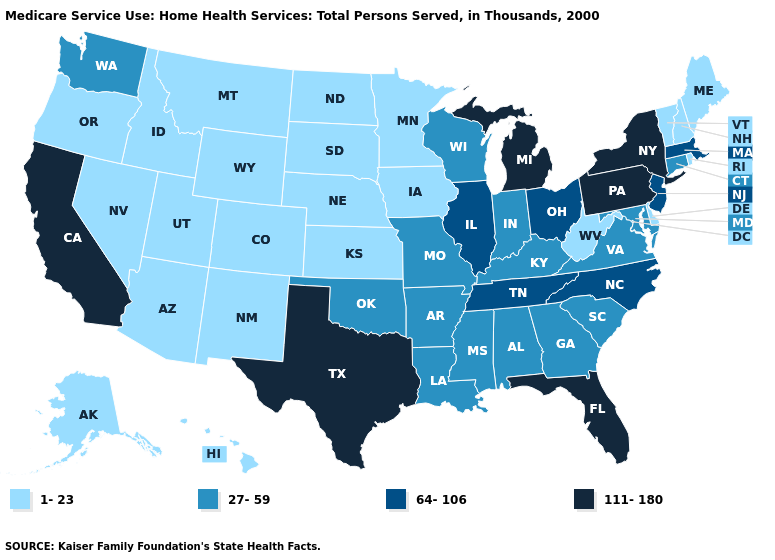Does Delaware have the lowest value in the South?
Keep it brief. Yes. Does Arkansas have the same value as Nevada?
Answer briefly. No. Does Illinois have the same value as Utah?
Concise answer only. No. What is the lowest value in states that border New Mexico?
Write a very short answer. 1-23. What is the value of Illinois?
Quick response, please. 64-106. Does Indiana have a higher value than North Dakota?
Give a very brief answer. Yes. Among the states that border Texas , which have the lowest value?
Give a very brief answer. New Mexico. Does the map have missing data?
Give a very brief answer. No. Among the states that border Tennessee , does Arkansas have the highest value?
Give a very brief answer. No. What is the lowest value in states that border Texas?
Write a very short answer. 1-23. What is the highest value in states that border Maine?
Answer briefly. 1-23. Name the states that have a value in the range 27-59?
Give a very brief answer. Alabama, Arkansas, Connecticut, Georgia, Indiana, Kentucky, Louisiana, Maryland, Mississippi, Missouri, Oklahoma, South Carolina, Virginia, Washington, Wisconsin. Among the states that border Ohio , does Michigan have the highest value?
Write a very short answer. Yes. What is the value of Tennessee?
Quick response, please. 64-106. Does Tennessee have the same value as North Carolina?
Keep it brief. Yes. 